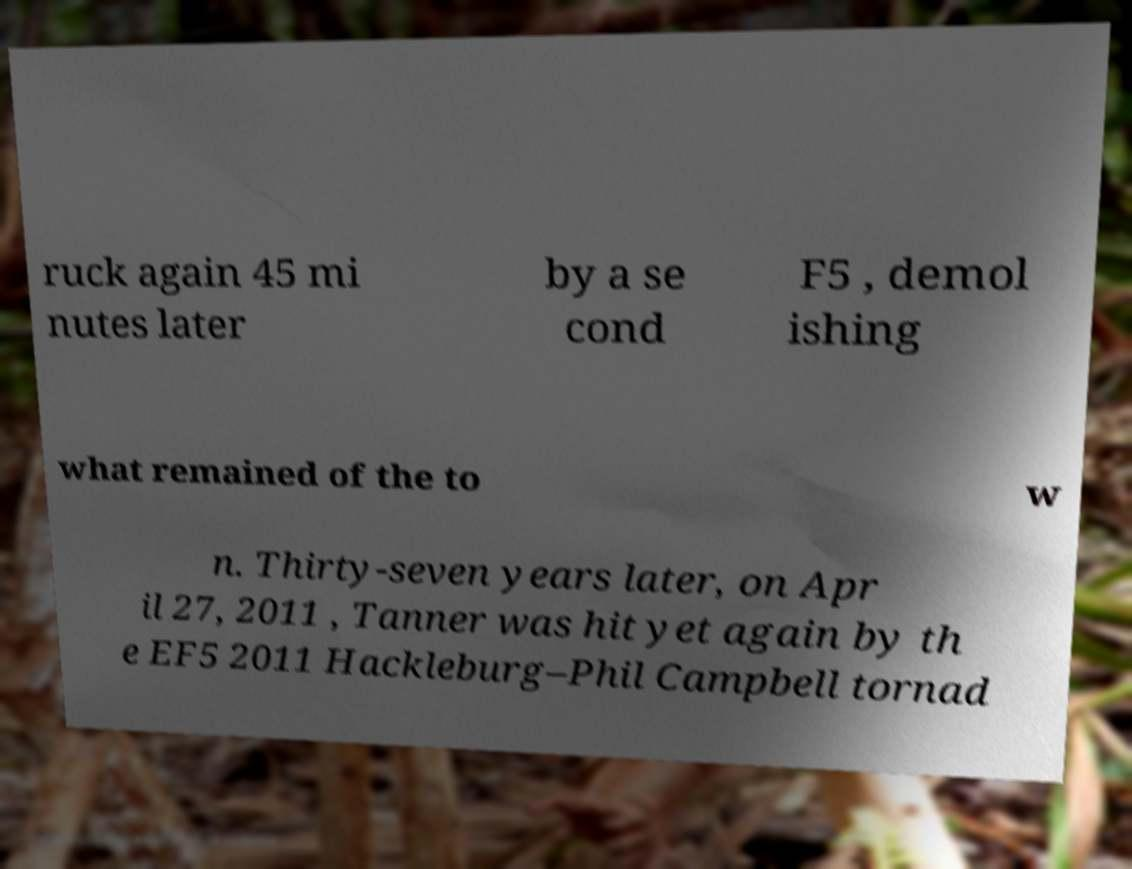There's text embedded in this image that I need extracted. Can you transcribe it verbatim? ruck again 45 mi nutes later by a se cond F5 , demol ishing what remained of the to w n. Thirty-seven years later, on Apr il 27, 2011 , Tanner was hit yet again by th e EF5 2011 Hackleburg–Phil Campbell tornad 